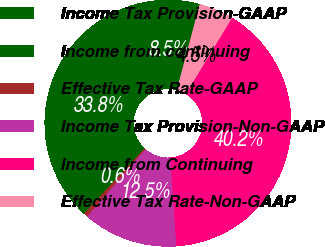Convert chart to OTSL. <chart><loc_0><loc_0><loc_500><loc_500><pie_chart><fcel>Income Tax Provision-GAAP<fcel>Income from continuing<fcel>Effective Tax Rate-GAAP<fcel>Income Tax Provision-Non-GAAP<fcel>Income from Continuing<fcel>Effective Tax Rate-Non-GAAP<nl><fcel>8.49%<fcel>33.75%<fcel>0.56%<fcel>12.46%<fcel>40.21%<fcel>4.53%<nl></chart> 